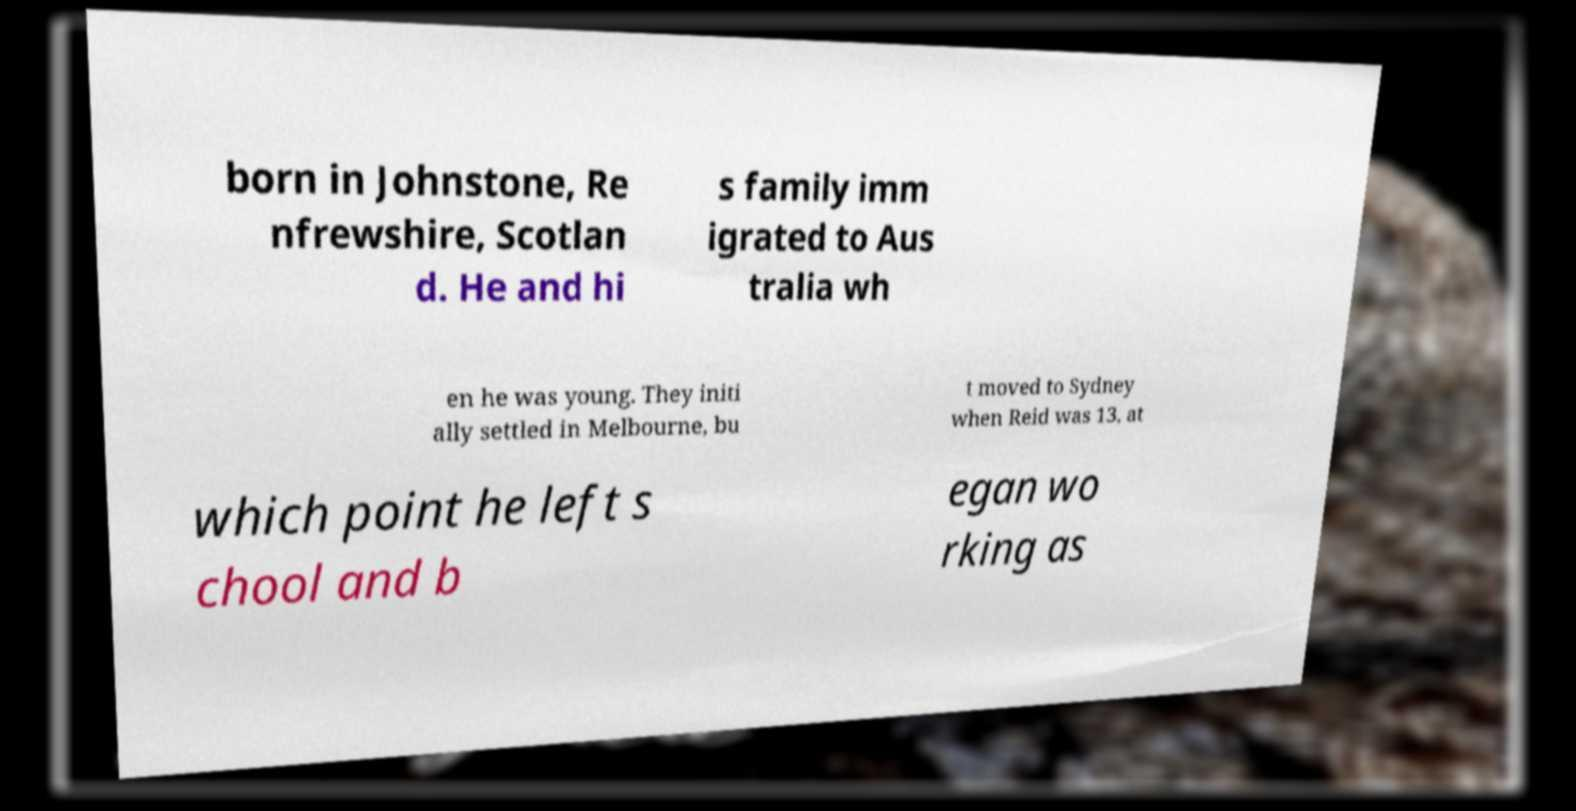Please identify and transcribe the text found in this image. born in Johnstone, Re nfrewshire, Scotlan d. He and hi s family imm igrated to Aus tralia wh en he was young. They initi ally settled in Melbourne, bu t moved to Sydney when Reid was 13, at which point he left s chool and b egan wo rking as 